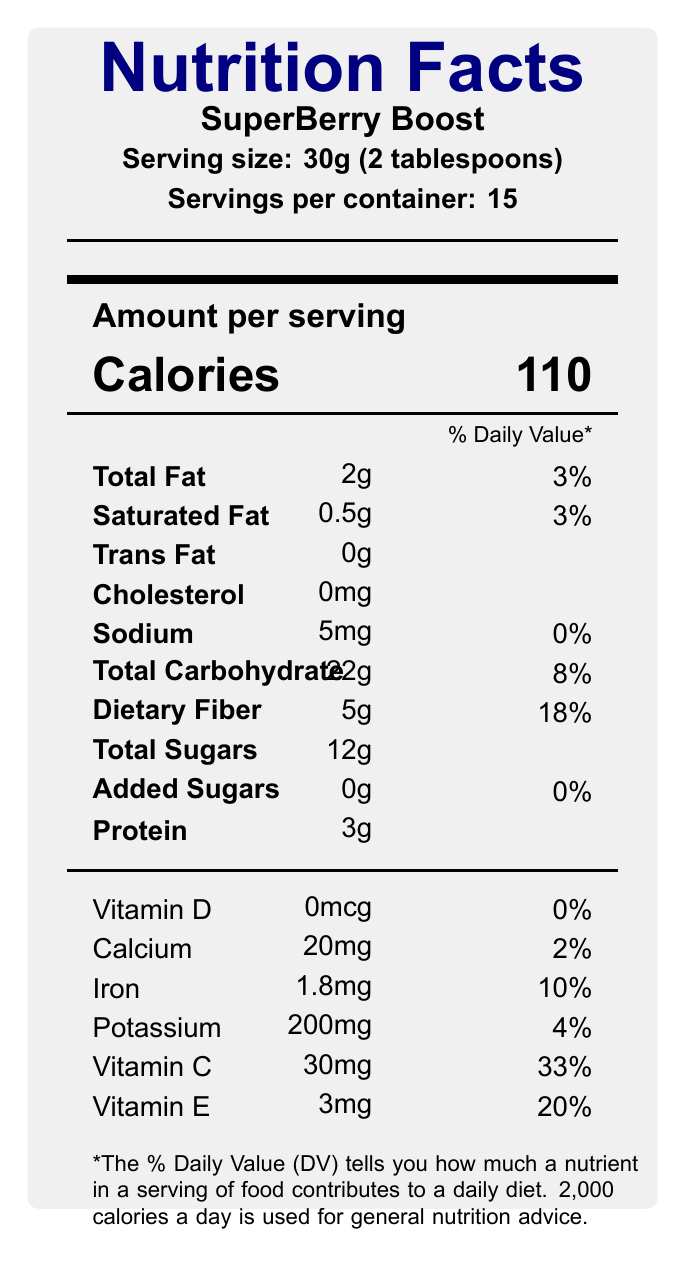what is the serving size of SuperBerry Boost? The serving size is clearly listed in the document under the product name "SuperBerry Boost."
Answer: 30g (2 tablespoons) how many servings are in one container of SuperBerry Boost? The document states that there are 15 servings per container.
Answer: 15 what is the total fat content per serving? The total fat content per serving is listed as 2g in the nutritional information.
Answer: 2g what percentage of the daily value is the dietary fiber content? The dietary fiber content is given as 5g, which corresponds to 18% of the daily value.
Answer: 18% how much calcium is in each serving? Each serving contains 20mg of calcium, as indicated in the vitamins and minerals section.
Answer: 20mg which of the following vitamins is present in the highest daily value percentage in SuperBerry Boost? A. Vitamin D B. Calcium C. Iron D. Vitamin C The percentages of daily values are Vitamin D: 0%, Calcium: 2%, Iron: 10%, Vitamin C: 33%; hence, Vitamin C has the highest daily value percentage.
Answer: D which one of these ingredients is NOT listed in SuperBerry Boost? A. Organic acai berries B. Organic goji berries C. Organic spirulina D. Organic blueberries The ingredient list includes Organic acai berries, Organic goji berries, Organic blueberries, Organic maca powder, and Organic chia seeds, but not Organic spirulina.
Answer: C is there any added sugar in SuperBerry Boost? The nutritional content specifies that there are 0g of added sugars per serving.
Answer: No what is the main idea promoted by the marketing claims? The marketing claims emphasize the product being "Packed with antioxidants," "Boosts immune system," "Improves cognitive function," "Enhances energy levels," and "Supports weight loss," all of which indicate a focus on health and wellness benefits.
Answer: Health and wellness benefits which cognitive biases are consumers likely to experience according to the psychological analysis? The document mentions that the "Halo effect" and "Confirmation bias" are cognitive biases that may influence consumer perception of the product.
Answer: Halo effect and Confirmation bias what is the calorie content per serving of SuperBerry Boost? Each serving provides 110 calories, as shown prominently in the nutritional information.
Answer: 110 calories how does the product's actual nutritional content compare to its marketing claims? The psychological analysis notes that the actual nutritional content, while beneficial, may not fully support all the bold claims made, indicating a potential gap between marketing language and reality.
Answer: While beneficial, the nutritional content may not fully support all claims can SuperBerry Boost be considered a low sodium product? With 5mg of sodium per serving and 0% daily value, the product can be considered low in sodium.
Answer: Yes how much protein does each serving offer? Each serving contains 3g of protein.
Answer: 3g what is the amount of total sugars per serving? The document states that there are 12g of total sugars per serving.
Answer: 12g how much iron does each serving of SuperBerry Boost provide? Each serving offers 1.8mg of iron, amounting to 10% of the daily value.
Answer: 1.8mg does the product contain any cholesterol? It is listed that there are 0mg of cholesterol per serving.
Answer: No is the daily value percentage for Vitamin D high in SuperBerry Boost? The daily value percentage for Vitamin D is 0%.
Answer: No how many milligrams of potassium are in each serving of SuperBerry Boost? Each serving contains 200mg of potassium.
Answer: 200mg what is the societal impact of promoting superfoods like SuperBerry Boost? The societal impact section mentions that such marketing may lead to unrealistic expectations about single products solving complex health issues and may contribute to health disparities by targeting affluent consumers.
Answer: Promotes unrealistic health expectations and can contribute to health disparities how much Vitamin E is included per serving? The document shows that each serving has 3mg of Vitamin E, corresponding to 20% of the daily value.
Answer: 3mg does the product make specific numerical claims about improving cognitive function? The psychological analysis notes the lack of quantifiable metrics for claims like "improves cognitive function," making it difficult to statistically validate these assertions.
Answer: No what is the daily value percentage of saturated fat in the product? Each serving contains 0.5g of saturated fat, which is 3% of the daily value.
Answer: 3% what biases might affect the perception of SuperBerry Boost? The psychological analysis section identifies the "Halo effect" and "Confirmation bias" as likely to influence consumer perceptions./Narrate the contribution of these biases to consumer's actions.
Answer: Halo effect and Confirmation bias what are the limitations in validating the product's marketing claims statistically? The statistical considerations section points out that the lack of quantifiable metrics for some claims and the potential for misleading percentage values without context are significant limitations in validating the marketing claims.
Answer: Lack of quantifiable metrics and misleading percentages 